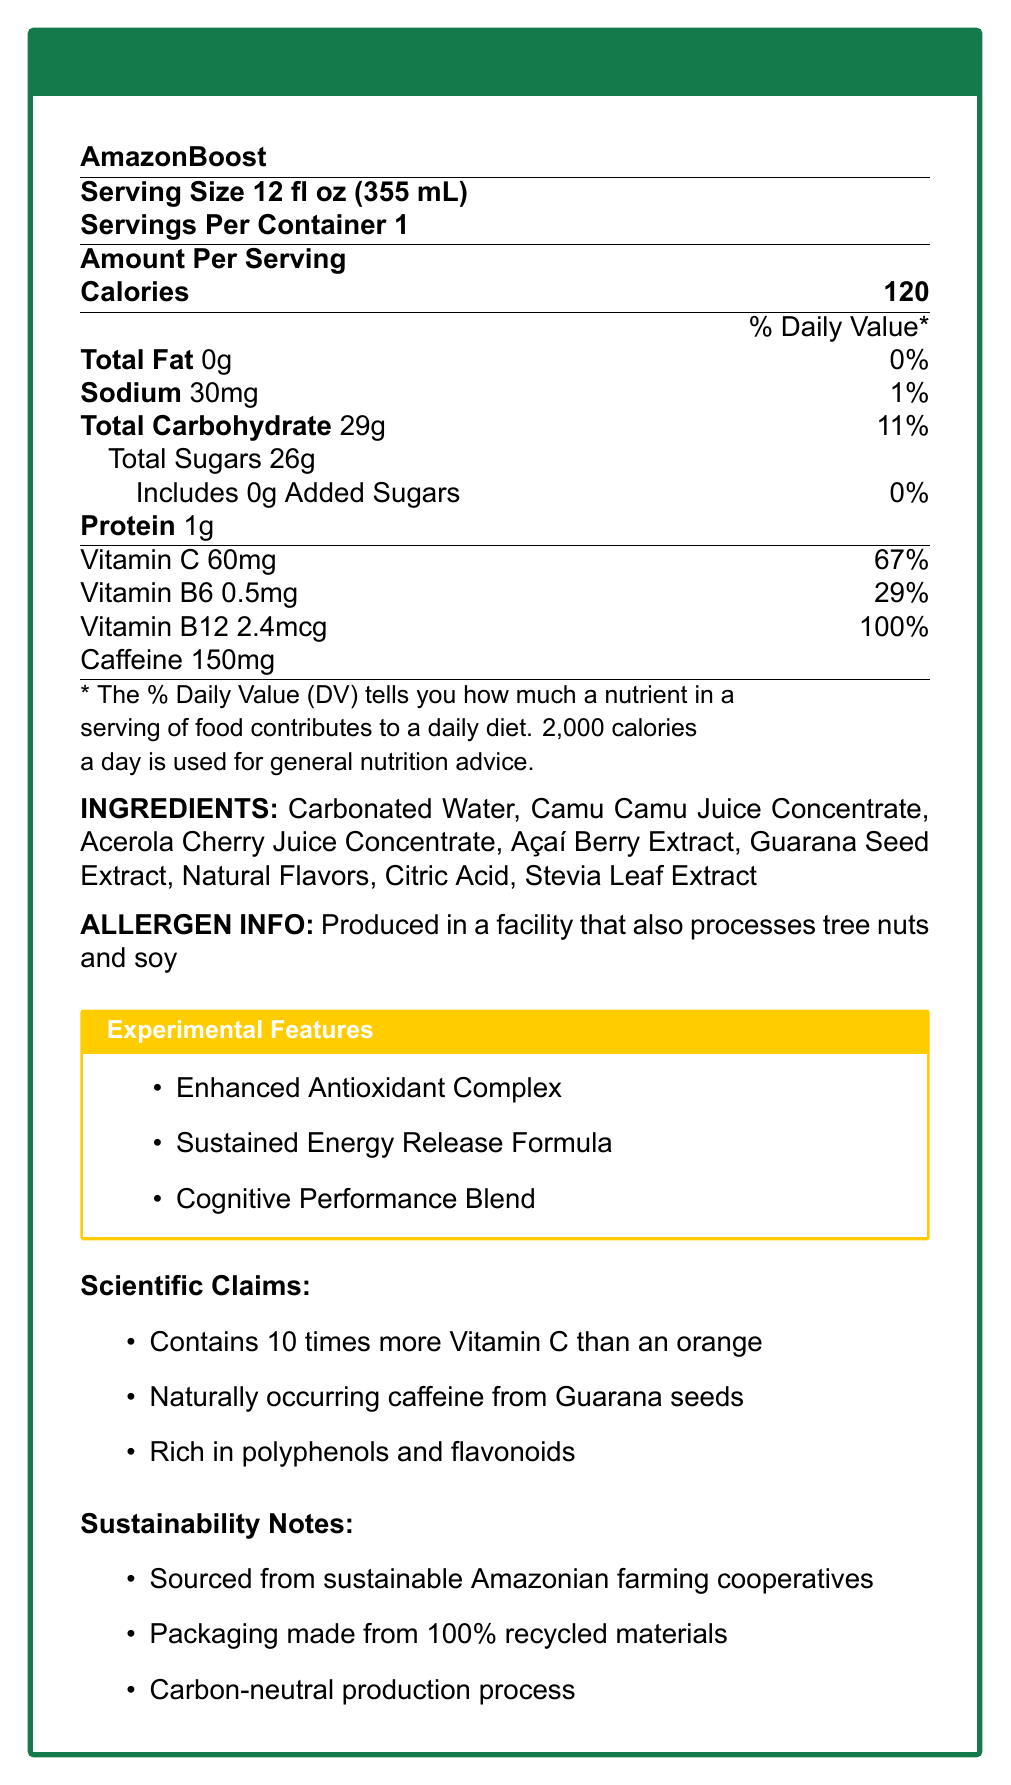what is the serving size of AmazonBoost? The serving size of AmazonBoost is explicitly mentioned near the top of the visualized document.
Answer: 12 fl oz (355 mL) how many calories are in one serving of AmazonBoost? The calories per serving are listed under the "Amount Per Serving" section of the document.
Answer: 120 how much sodium does AmazonBoost contain? The amount of sodium is detailed under the nutritional details section as 30mg.
Answer: 30mg what is the percentage of daily value for Vitamin B6 in AmazonBoost? The percentage of daily value for Vitamin B6 is mentioned as 29%.
Answer: 29% what is the protein content in AmazonBoost? The protein content is stated directly under the nutritional details.
Answer: 1g what type of caffeine is in AmazonBoost? A. Synthetic Caffeine B. Green Tea Extract C. Guarana Seed Extract D. Coffee Bean Extract The document mentions that the caffeine in AmazonBoost is from "Naturally occurring caffeine from Guarana seeds."
Answer: C. Guarana Seed Extract which of the following is NOT an ingredient in AmazonBoost? A. Carbonated Water B. Citric Acid C. Sugar D. Stevia Leaf Extract The ingredient list includes Carbonated Water, Citric Acid, Stevia Leaf Extract, but not plain Sugar.
Answer: C. Sugar does AmazonBoost contain any added sugars? The document lists that it includes 0g of added sugars.
Answer: No is AmazonBoost sourced in an environmentally sustainable way? The sustainability notes mention that it is sourced from sustainable Amazonian farming cooperatives, packaging made from 100% recycled materials, and has a carbon-neutral production process.
Answer: Yes summarize the main features and nutritional content of AmazonBoost. The document provides information on the serving size, nutritional content including calories, fat, sodium, carbohydrates, sugars, protein, vitamins, and caffeine content. Furthermore, it details the ingredients, experimental features, scientific claims, and sustainability notes.
Answer: AmazonBoost is an energy drink made from rare Amazonian fruits with a serving size of 12 fl oz. It has 120 calories per serving with 0g of total fat, 30mg of sodium, 29g of total carbohydrates including 26g of total sugars, and 1g of protein. It is rich in Vitamin C, Vitamin B6, and Vitamin B12 and has 150mg of caffeine. Ingredients include natural juice concentrates and extracts. The product also features enhanced antioxidants, sustained energy release, and cognitive performance blends. Additionally, it is produced sustainably in terms of sourcing, packaging, and production. who are the target consumers for AmazonBoost? The document does not provide information on the target consumers, so this cannot be determined from the visual information provided.
Answer: Cannot be determined 